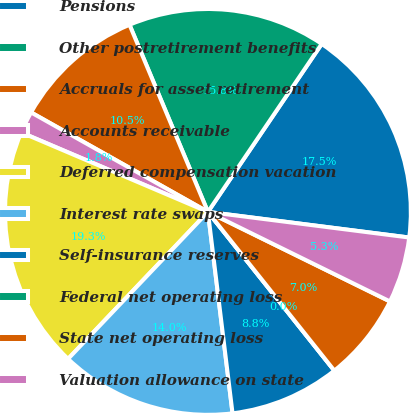<chart> <loc_0><loc_0><loc_500><loc_500><pie_chart><fcel>Pensions<fcel>Other postretirement benefits<fcel>Accruals for asset retirement<fcel>Accounts receivable<fcel>Deferred compensation vacation<fcel>Interest rate swaps<fcel>Self-insurance reserves<fcel>Federal net operating loss<fcel>State net operating loss<fcel>Valuation allowance on state<nl><fcel>17.54%<fcel>15.79%<fcel>10.53%<fcel>1.75%<fcel>19.3%<fcel>14.04%<fcel>8.77%<fcel>0.0%<fcel>7.02%<fcel>5.26%<nl></chart> 